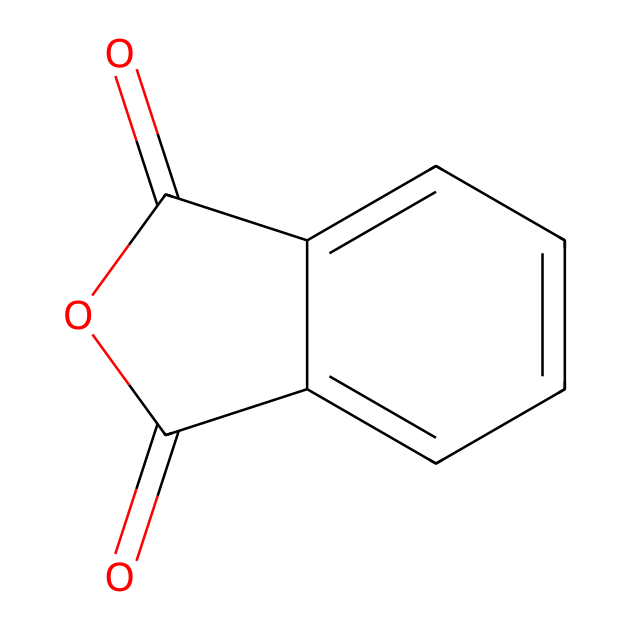what is the name of this chemical? The SMILES representation corresponds to a chemical that is known as phthalic anhydride because the structure depicts the anhydride form of phthalic acid, characterized by its cyclic dicarbonyl structure.
Answer: phthalic anhydride how many carbon atoms are present in this molecule? By analyzing the SMILES structure, we can count the carbon atoms. The core structure has 8 carbon atoms from the aromatic ring and the cyclic anhydride component, totaling 8 carbon atoms.
Answer: 8 what type of functional groups are present in this molecule? The structure indicates the presence of anhydride functional groups due to the carbonyl (C=O) connections, and there is also an aromatic ring contributing to its properties.
Answer: anhydride how many oxygen atoms are in the phthalic anhydride structure? From the SMILES representation, we see there are two carbonyl oxygens in the cyclic part and one oxygen in the bridge of the anhydride, thus totaling 3 oxygen atoms in the structure.
Answer: 3 is phthalic anhydride a solid or a liquid at room temperature? The physical state of phthalic anhydride, based on its melting point (131 degrees Celsius), indicates that it exists as a solid at room temperature (approximately 25 degrees Celsius).
Answer: solid what is the primary use of phthalic anhydride in road marking paints? Phthalic anhydride is primarily used as a reactant in the production of resins and coatings, enhancing adhesion and durability, which is essential for road marking paints.
Answer: resins 